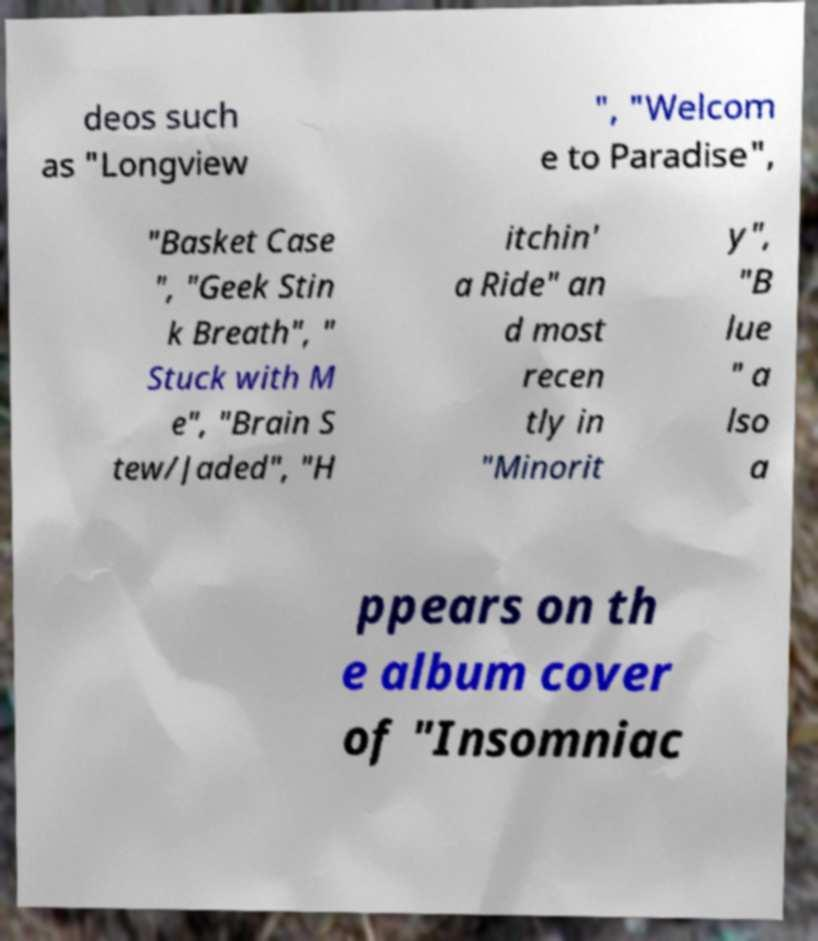Please identify and transcribe the text found in this image. deos such as "Longview ", "Welcom e to Paradise", "Basket Case ", "Geek Stin k Breath", " Stuck with M e", "Brain S tew/Jaded", "H itchin' a Ride" an d most recen tly in "Minorit y", "B lue " a lso a ppears on th e album cover of "Insomniac 